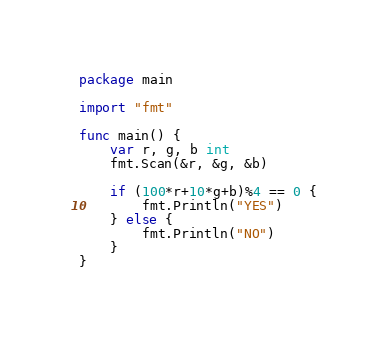Convert code to text. <code><loc_0><loc_0><loc_500><loc_500><_Go_>package main

import "fmt"

func main() {
	var r, g, b int
	fmt.Scan(&r, &g, &b)

	if (100*r+10*g+b)%4 == 0 {
		fmt.Println("YES")
	} else {
		fmt.Println("NO")
	}
}
</code> 